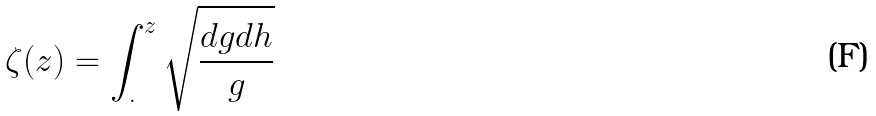<formula> <loc_0><loc_0><loc_500><loc_500>\zeta ( z ) = \int _ { . } ^ { z } \sqrt { \frac { d g d h } { g } }</formula> 